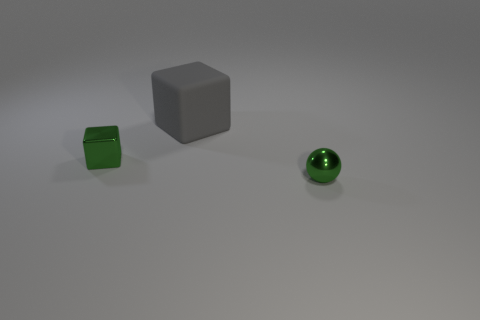Are there any other things that are made of the same material as the big block?
Provide a short and direct response. No. There is a thing that is the same color as the tiny metallic block; what is its material?
Your answer should be very brief. Metal. Is the number of small metallic objects left of the tiny sphere greater than the number of blue matte cubes?
Your response must be concise. Yes. What shape is the object in front of the small thing that is behind the small green metal ball to the right of the metal block?
Provide a succinct answer. Sphere. Does the green metal thing that is to the left of the big gray rubber thing have the same shape as the gray matte thing that is behind the green metallic sphere?
Offer a very short reply. Yes. Is there any other thing that is the same size as the gray block?
Your answer should be compact. No. What number of cylinders are either cyan things or rubber objects?
Offer a terse response. 0. Are the green ball and the green cube made of the same material?
Your response must be concise. Yes. How many other things are the same color as the large matte cube?
Your answer should be compact. 0. The tiny green object that is to the left of the sphere has what shape?
Your response must be concise. Cube. 